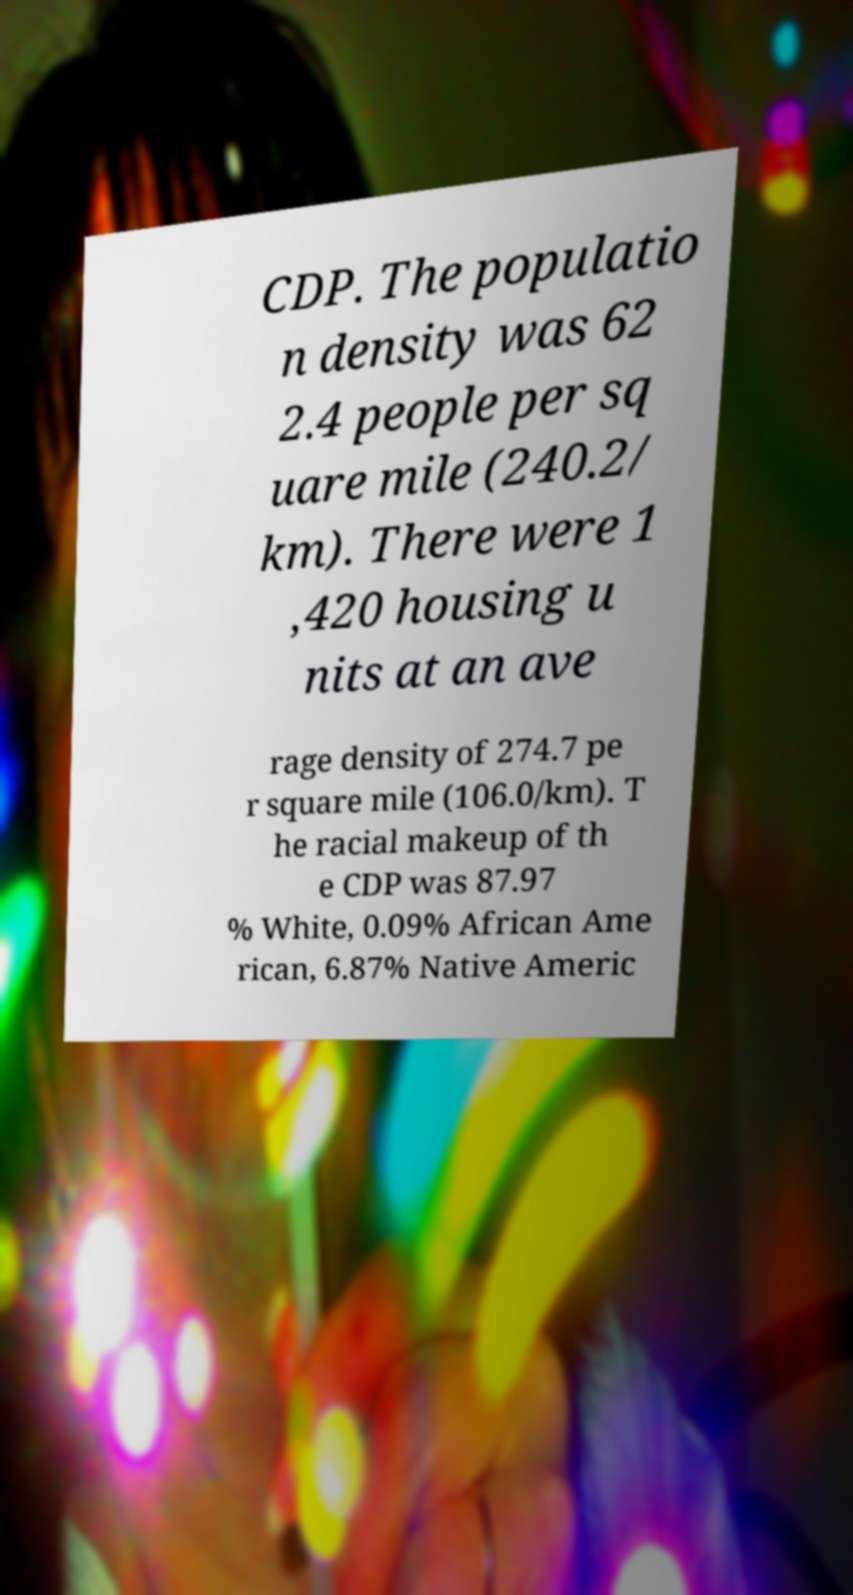Please read and relay the text visible in this image. What does it say? CDP. The populatio n density was 62 2.4 people per sq uare mile (240.2/ km). There were 1 ,420 housing u nits at an ave rage density of 274.7 pe r square mile (106.0/km). T he racial makeup of th e CDP was 87.97 % White, 0.09% African Ame rican, 6.87% Native Americ 